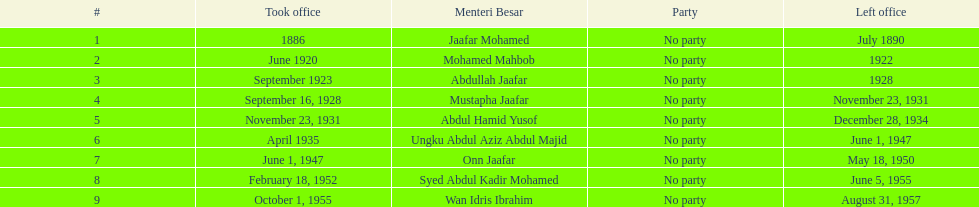Who spend the most amount of time in office? Ungku Abdul Aziz Abdul Majid. Give me the full table as a dictionary. {'header': ['#', 'Took office', 'Menteri Besar', 'Party', 'Left office'], 'rows': [['1', '1886', 'Jaafar Mohamed', 'No party', 'July 1890'], ['2', 'June 1920', 'Mohamed Mahbob', 'No party', '1922'], ['3', 'September 1923', 'Abdullah Jaafar', 'No party', '1928'], ['4', 'September 16, 1928', 'Mustapha Jaafar', 'No party', 'November 23, 1931'], ['5', 'November 23, 1931', 'Abdul Hamid Yusof', 'No party', 'December 28, 1934'], ['6', 'April 1935', 'Ungku Abdul Aziz Abdul Majid', 'No party', 'June 1, 1947'], ['7', 'June 1, 1947', 'Onn Jaafar', 'No party', 'May 18, 1950'], ['8', 'February 18, 1952', 'Syed Abdul Kadir Mohamed', 'No party', 'June 5, 1955'], ['9', 'October 1, 1955', 'Wan Idris Ibrahim', 'No party', 'August 31, 1957']]} 